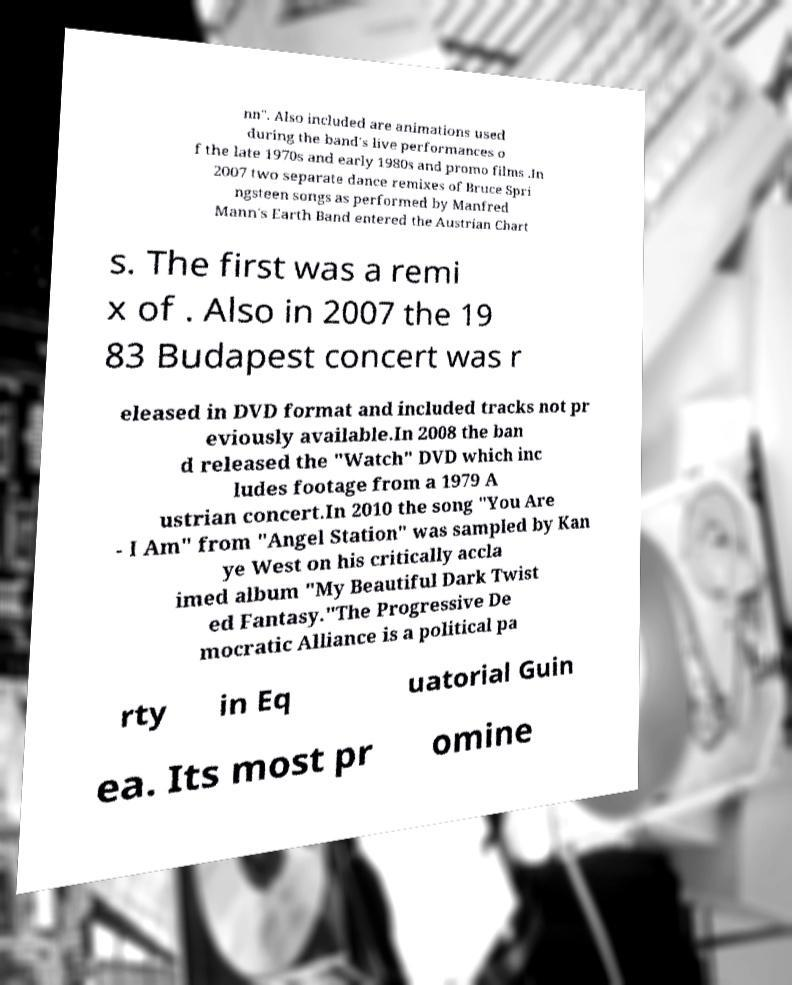For documentation purposes, I need the text within this image transcribed. Could you provide that? nn". Also included are animations used during the band's live performances o f the late 1970s and early 1980s and promo films .In 2007 two separate dance remixes of Bruce Spri ngsteen songs as performed by Manfred Mann's Earth Band entered the Austrian Chart s. The first was a remi x of . Also in 2007 the 19 83 Budapest concert was r eleased in DVD format and included tracks not pr eviously available.In 2008 the ban d released the "Watch" DVD which inc ludes footage from a 1979 A ustrian concert.In 2010 the song "You Are - I Am" from "Angel Station" was sampled by Kan ye West on his critically accla imed album "My Beautiful Dark Twist ed Fantasy."The Progressive De mocratic Alliance is a political pa rty in Eq uatorial Guin ea. Its most pr omine 